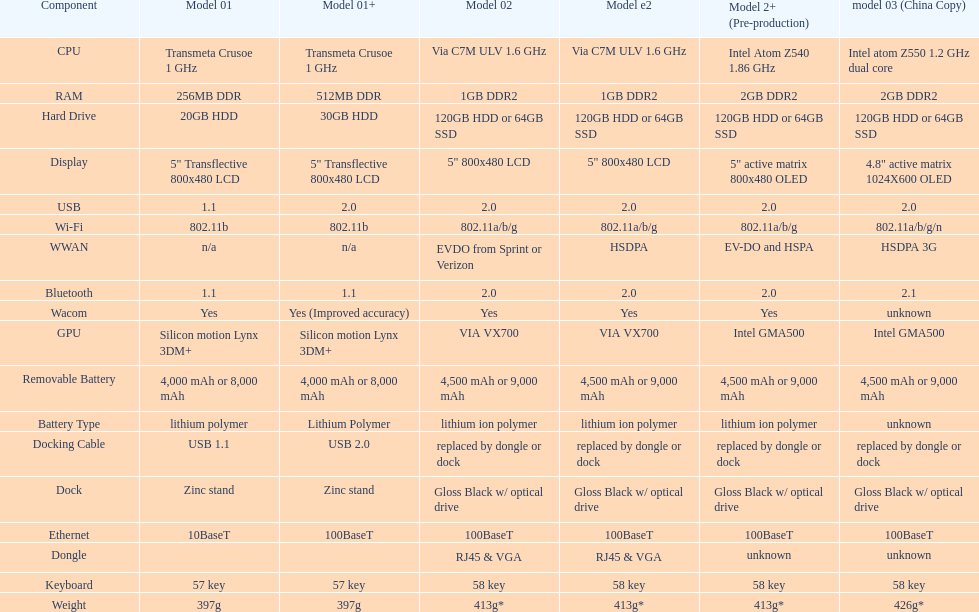Which model weighs the most, according to the table? Model 03 (china copy). 